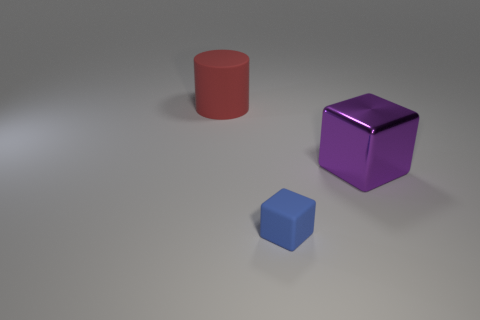Does the big metallic cube behind the small thing have the same color as the rubber thing that is to the left of the small object?
Your answer should be very brief. No. How many things are in front of the red object and behind the blue rubber cube?
Give a very brief answer. 1. What is the red cylinder made of?
Offer a terse response. Rubber. What is the shape of the other thing that is the same size as the red matte thing?
Keep it short and to the point. Cube. Are the thing in front of the purple block and the object that is behind the large purple thing made of the same material?
Provide a succinct answer. Yes. How many big shiny things are there?
Keep it short and to the point. 1. What number of purple metal things are the same shape as the tiny blue matte thing?
Give a very brief answer. 1. Is the shape of the big metallic thing the same as the tiny thing?
Offer a very short reply. Yes. What is the size of the purple block?
Give a very brief answer. Large. How many red rubber things have the same size as the shiny object?
Provide a succinct answer. 1. 